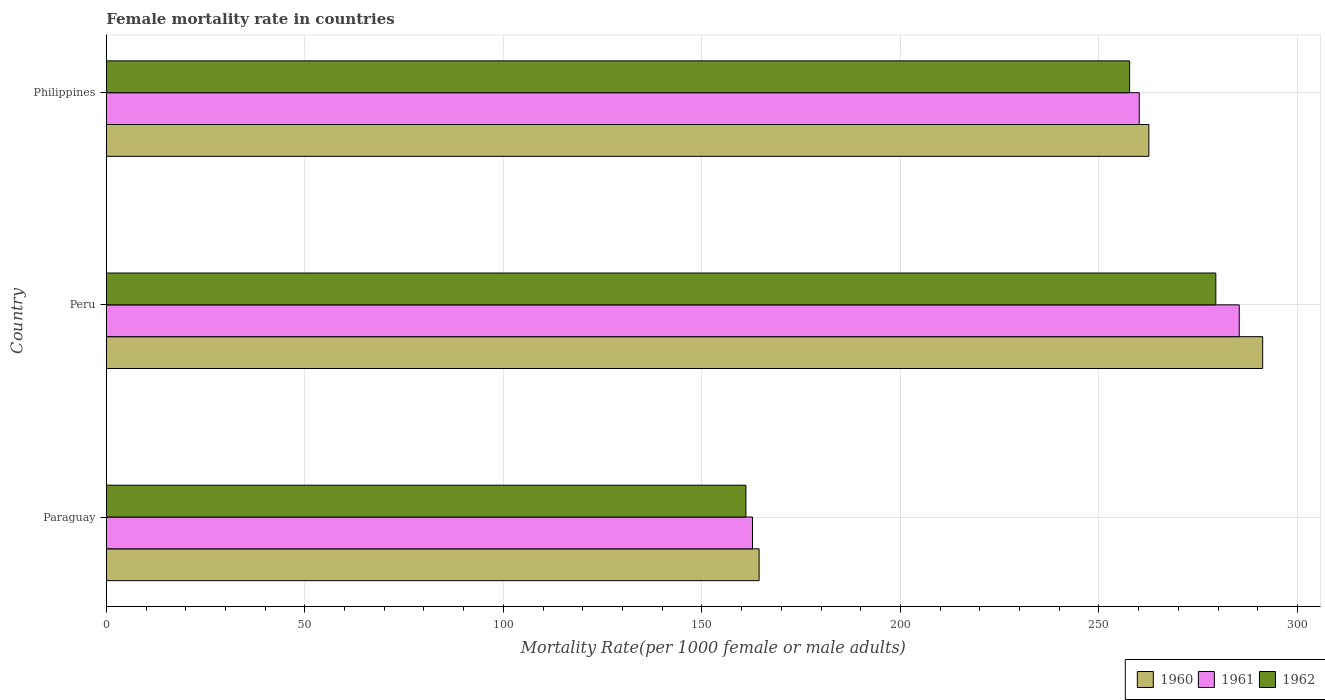How many different coloured bars are there?
Your answer should be very brief. 3. Are the number of bars per tick equal to the number of legend labels?
Your response must be concise. Yes. Are the number of bars on each tick of the Y-axis equal?
Offer a terse response. Yes. How many bars are there on the 3rd tick from the bottom?
Make the answer very short. 3. What is the label of the 2nd group of bars from the top?
Ensure brevity in your answer.  Peru. What is the female mortality rate in 1961 in Philippines?
Offer a terse response. 260.15. Across all countries, what is the maximum female mortality rate in 1961?
Ensure brevity in your answer.  285.33. Across all countries, what is the minimum female mortality rate in 1961?
Offer a very short reply. 162.75. In which country was the female mortality rate in 1960 maximum?
Make the answer very short. Peru. In which country was the female mortality rate in 1962 minimum?
Provide a short and direct response. Paraguay. What is the total female mortality rate in 1961 in the graph?
Your answer should be compact. 708.23. What is the difference between the female mortality rate in 1962 in Peru and that in Philippines?
Keep it short and to the point. 21.71. What is the difference between the female mortality rate in 1962 in Philippines and the female mortality rate in 1960 in Paraguay?
Offer a terse response. 93.32. What is the average female mortality rate in 1961 per country?
Offer a terse response. 236.08. What is the difference between the female mortality rate in 1961 and female mortality rate in 1962 in Paraguay?
Offer a very short reply. 1.66. In how many countries, is the female mortality rate in 1961 greater than 30 ?
Provide a succinct answer. 3. What is the ratio of the female mortality rate in 1960 in Peru to that in Philippines?
Your answer should be very brief. 1.11. What is the difference between the highest and the second highest female mortality rate in 1961?
Your answer should be compact. 25.19. What is the difference between the highest and the lowest female mortality rate in 1961?
Keep it short and to the point. 122.59. In how many countries, is the female mortality rate in 1961 greater than the average female mortality rate in 1961 taken over all countries?
Make the answer very short. 2. Is the sum of the female mortality rate in 1960 in Paraguay and Peru greater than the maximum female mortality rate in 1961 across all countries?
Your response must be concise. Yes. What does the 2nd bar from the bottom in Peru represents?
Your answer should be compact. 1961. Is it the case that in every country, the sum of the female mortality rate in 1961 and female mortality rate in 1960 is greater than the female mortality rate in 1962?
Keep it short and to the point. Yes. Are all the bars in the graph horizontal?
Your answer should be compact. Yes. How many countries are there in the graph?
Give a very brief answer. 3. What is the difference between two consecutive major ticks on the X-axis?
Offer a very short reply. 50. Are the values on the major ticks of X-axis written in scientific E-notation?
Provide a short and direct response. No. Where does the legend appear in the graph?
Ensure brevity in your answer.  Bottom right. How many legend labels are there?
Provide a short and direct response. 3. How are the legend labels stacked?
Your answer should be very brief. Horizontal. What is the title of the graph?
Keep it short and to the point. Female mortality rate in countries. What is the label or title of the X-axis?
Make the answer very short. Mortality Rate(per 1000 female or male adults). What is the Mortality Rate(per 1000 female or male adults) of 1960 in Paraguay?
Ensure brevity in your answer.  164.41. What is the Mortality Rate(per 1000 female or male adults) of 1961 in Paraguay?
Your answer should be compact. 162.75. What is the Mortality Rate(per 1000 female or male adults) in 1962 in Paraguay?
Provide a succinct answer. 161.08. What is the Mortality Rate(per 1000 female or male adults) of 1960 in Peru?
Give a very brief answer. 291.23. What is the Mortality Rate(per 1000 female or male adults) of 1961 in Peru?
Make the answer very short. 285.33. What is the Mortality Rate(per 1000 female or male adults) in 1962 in Peru?
Your response must be concise. 279.43. What is the Mortality Rate(per 1000 female or male adults) of 1960 in Philippines?
Offer a very short reply. 262.57. What is the Mortality Rate(per 1000 female or male adults) of 1961 in Philippines?
Offer a very short reply. 260.15. What is the Mortality Rate(per 1000 female or male adults) of 1962 in Philippines?
Provide a short and direct response. 257.72. Across all countries, what is the maximum Mortality Rate(per 1000 female or male adults) in 1960?
Your answer should be compact. 291.23. Across all countries, what is the maximum Mortality Rate(per 1000 female or male adults) of 1961?
Offer a very short reply. 285.33. Across all countries, what is the maximum Mortality Rate(per 1000 female or male adults) of 1962?
Give a very brief answer. 279.43. Across all countries, what is the minimum Mortality Rate(per 1000 female or male adults) of 1960?
Provide a succinct answer. 164.41. Across all countries, what is the minimum Mortality Rate(per 1000 female or male adults) of 1961?
Provide a succinct answer. 162.75. Across all countries, what is the minimum Mortality Rate(per 1000 female or male adults) of 1962?
Give a very brief answer. 161.08. What is the total Mortality Rate(per 1000 female or male adults) in 1960 in the graph?
Offer a terse response. 718.21. What is the total Mortality Rate(per 1000 female or male adults) of 1961 in the graph?
Provide a short and direct response. 708.23. What is the total Mortality Rate(per 1000 female or male adults) of 1962 in the graph?
Make the answer very short. 698.24. What is the difference between the Mortality Rate(per 1000 female or male adults) in 1960 in Paraguay and that in Peru?
Provide a short and direct response. -126.83. What is the difference between the Mortality Rate(per 1000 female or male adults) of 1961 in Paraguay and that in Peru?
Offer a very short reply. -122.59. What is the difference between the Mortality Rate(per 1000 female or male adults) in 1962 in Paraguay and that in Peru?
Keep it short and to the point. -118.35. What is the difference between the Mortality Rate(per 1000 female or male adults) of 1960 in Paraguay and that in Philippines?
Your answer should be compact. -98.17. What is the difference between the Mortality Rate(per 1000 female or male adults) in 1961 in Paraguay and that in Philippines?
Give a very brief answer. -97.4. What is the difference between the Mortality Rate(per 1000 female or male adults) of 1962 in Paraguay and that in Philippines?
Give a very brief answer. -96.64. What is the difference between the Mortality Rate(per 1000 female or male adults) of 1960 in Peru and that in Philippines?
Make the answer very short. 28.66. What is the difference between the Mortality Rate(per 1000 female or male adults) in 1961 in Peru and that in Philippines?
Ensure brevity in your answer.  25.18. What is the difference between the Mortality Rate(per 1000 female or male adults) of 1962 in Peru and that in Philippines?
Provide a short and direct response. 21.71. What is the difference between the Mortality Rate(per 1000 female or male adults) of 1960 in Paraguay and the Mortality Rate(per 1000 female or male adults) of 1961 in Peru?
Give a very brief answer. -120.93. What is the difference between the Mortality Rate(per 1000 female or male adults) in 1960 in Paraguay and the Mortality Rate(per 1000 female or male adults) in 1962 in Peru?
Your answer should be very brief. -115.03. What is the difference between the Mortality Rate(per 1000 female or male adults) in 1961 in Paraguay and the Mortality Rate(per 1000 female or male adults) in 1962 in Peru?
Provide a short and direct response. -116.69. What is the difference between the Mortality Rate(per 1000 female or male adults) in 1960 in Paraguay and the Mortality Rate(per 1000 female or male adults) in 1961 in Philippines?
Make the answer very short. -95.74. What is the difference between the Mortality Rate(per 1000 female or male adults) of 1960 in Paraguay and the Mortality Rate(per 1000 female or male adults) of 1962 in Philippines?
Make the answer very short. -93.32. What is the difference between the Mortality Rate(per 1000 female or male adults) in 1961 in Paraguay and the Mortality Rate(per 1000 female or male adults) in 1962 in Philippines?
Your answer should be very brief. -94.98. What is the difference between the Mortality Rate(per 1000 female or male adults) in 1960 in Peru and the Mortality Rate(per 1000 female or male adults) in 1961 in Philippines?
Provide a short and direct response. 31.09. What is the difference between the Mortality Rate(per 1000 female or male adults) in 1960 in Peru and the Mortality Rate(per 1000 female or male adults) in 1962 in Philippines?
Offer a very short reply. 33.51. What is the difference between the Mortality Rate(per 1000 female or male adults) in 1961 in Peru and the Mortality Rate(per 1000 female or male adults) in 1962 in Philippines?
Keep it short and to the point. 27.61. What is the average Mortality Rate(per 1000 female or male adults) in 1960 per country?
Your answer should be very brief. 239.4. What is the average Mortality Rate(per 1000 female or male adults) of 1961 per country?
Keep it short and to the point. 236.08. What is the average Mortality Rate(per 1000 female or male adults) of 1962 per country?
Make the answer very short. 232.75. What is the difference between the Mortality Rate(per 1000 female or male adults) in 1960 and Mortality Rate(per 1000 female or male adults) in 1961 in Paraguay?
Your response must be concise. 1.66. What is the difference between the Mortality Rate(per 1000 female or male adults) of 1960 and Mortality Rate(per 1000 female or male adults) of 1962 in Paraguay?
Offer a terse response. 3.33. What is the difference between the Mortality Rate(per 1000 female or male adults) in 1961 and Mortality Rate(per 1000 female or male adults) in 1962 in Paraguay?
Provide a short and direct response. 1.66. What is the difference between the Mortality Rate(per 1000 female or male adults) of 1960 and Mortality Rate(per 1000 female or male adults) of 1961 in Peru?
Give a very brief answer. 5.9. What is the difference between the Mortality Rate(per 1000 female or male adults) of 1960 and Mortality Rate(per 1000 female or male adults) of 1961 in Philippines?
Your response must be concise. 2.42. What is the difference between the Mortality Rate(per 1000 female or male adults) of 1960 and Mortality Rate(per 1000 female or male adults) of 1962 in Philippines?
Make the answer very short. 4.85. What is the difference between the Mortality Rate(per 1000 female or male adults) in 1961 and Mortality Rate(per 1000 female or male adults) in 1962 in Philippines?
Your answer should be very brief. 2.42. What is the ratio of the Mortality Rate(per 1000 female or male adults) of 1960 in Paraguay to that in Peru?
Provide a succinct answer. 0.56. What is the ratio of the Mortality Rate(per 1000 female or male adults) in 1961 in Paraguay to that in Peru?
Make the answer very short. 0.57. What is the ratio of the Mortality Rate(per 1000 female or male adults) of 1962 in Paraguay to that in Peru?
Offer a terse response. 0.58. What is the ratio of the Mortality Rate(per 1000 female or male adults) of 1960 in Paraguay to that in Philippines?
Keep it short and to the point. 0.63. What is the ratio of the Mortality Rate(per 1000 female or male adults) in 1961 in Paraguay to that in Philippines?
Your response must be concise. 0.63. What is the ratio of the Mortality Rate(per 1000 female or male adults) of 1960 in Peru to that in Philippines?
Provide a short and direct response. 1.11. What is the ratio of the Mortality Rate(per 1000 female or male adults) of 1961 in Peru to that in Philippines?
Your answer should be compact. 1.1. What is the ratio of the Mortality Rate(per 1000 female or male adults) in 1962 in Peru to that in Philippines?
Offer a very short reply. 1.08. What is the difference between the highest and the second highest Mortality Rate(per 1000 female or male adults) of 1960?
Your answer should be very brief. 28.66. What is the difference between the highest and the second highest Mortality Rate(per 1000 female or male adults) in 1961?
Provide a succinct answer. 25.18. What is the difference between the highest and the second highest Mortality Rate(per 1000 female or male adults) in 1962?
Keep it short and to the point. 21.71. What is the difference between the highest and the lowest Mortality Rate(per 1000 female or male adults) of 1960?
Provide a succinct answer. 126.83. What is the difference between the highest and the lowest Mortality Rate(per 1000 female or male adults) in 1961?
Provide a succinct answer. 122.59. What is the difference between the highest and the lowest Mortality Rate(per 1000 female or male adults) in 1962?
Make the answer very short. 118.35. 